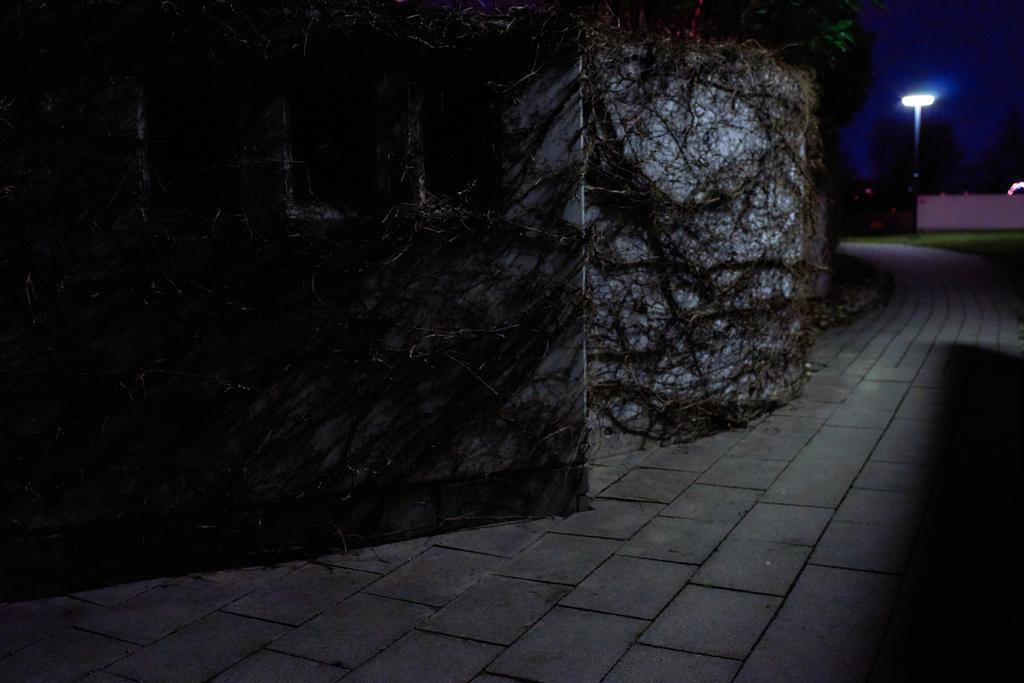Describe this image in one or two sentences. In this picture I can see roots on the wall. I can see walk way. I can see green grass. I can see a street light at the top right hand corner. 